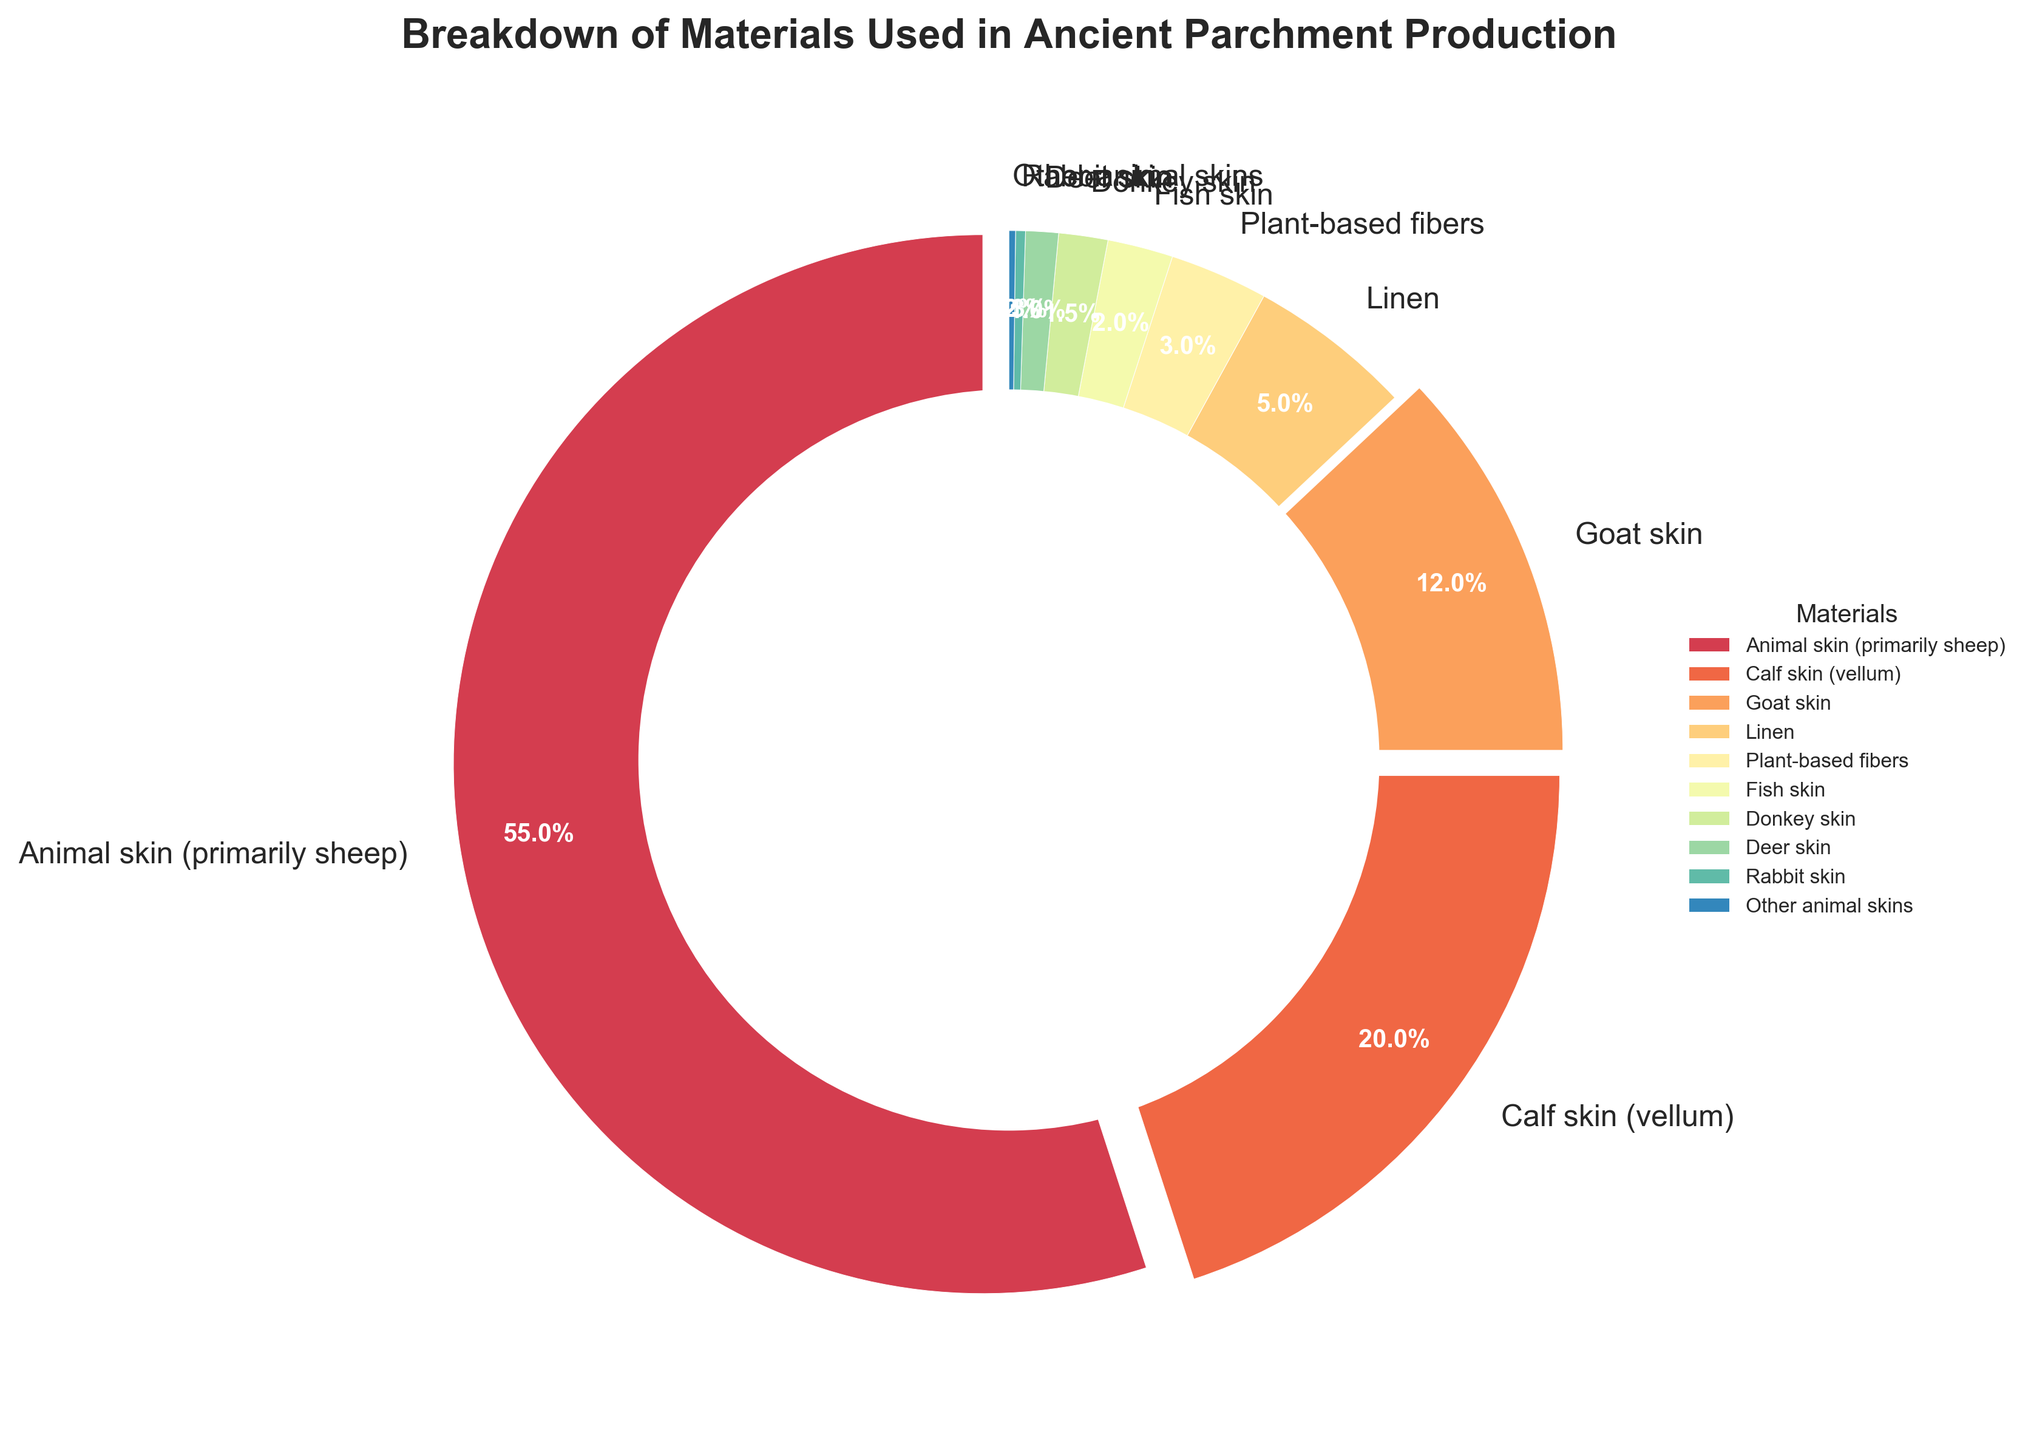What's the largest material used in ancient parchment production by percentage? From the figure, identify the material with the highest percentage. The material segment with the largest slice represents the highest percentage, which is 'Animal skin (primarily sheep)'
Answer: Animal skin (primarily sheep) What is the difference in percentage between animal skin (primarily sheep) and calf skin (vellum)? From the pie chart, find the percentages of both 'Animal skin (primarily sheep)' and 'Calf skin (vellum)'. The percentage for 'Animal skin (primarily sheep)' is 55% and for 'Calf skin (vellum)' is 20%. Subtract the percentage of 'Calf skin (vellum)' from 'Animal skin (primarily sheep)' to get the difference: 55% - 20% = 35%
Answer: 35% How many materials are used in ancient parchment production at a percentage less than 5%? Count the segments of the pie chart that represent percentages less than 5%. These materials are Linen, Plant-based fibers, Fish skin, Donkey skin, Deer skin, Rabbit skin, and Other animal skins. There are 7 segments
Answer: 7 Which material has the smallest representation in the chart? Identify the smallest slice in the pie chart. The smallest segment represents 'Other animal skins' with a percentage of 0.2%
Answer: Other animal skins By how much is goat skin more used compared to fish skin in percentage? From the pie chart, find the percentages of 'Goat skin' and 'Fish skin'. Goat skin is 12% and fish skin is 2%. Subtract the fish skin percentage from the goat skin percentage: 12% - 2% = 10%
Answer: 10% What is the total percentage of parchment materials that are not derived from animal skins? Sum the percentages of the materials that are not from animal skins: Linen (5%) + Plant-based fibers (3%). The total percentage is 5% + 3% = 8%
Answer: 8% What percentage of parchment material is from animal skins, excluding sheep, calf, and goat skins? Sum the percentages of parchment materials excluding sheep, calf, and goat skins. These materials are Fish skin (2%), Donkey skin (1.5%), Deer skin (1%), Rabbit skin (0.3%), and Other animal skins (0.2%). Add their percentages: 2% + 1.5% + 1% + 0.3% + 0.2% = 5%
Answer: 5% Which materials have a percentage representation between 1% and 3%? Check the segments of the pie chart that fall within this range. These materials are Fish skin (2%), Donkey skin (1.5%), Deer skin (1%), and exclude any material with percentages outside of this range
Answer: Fish skin, Donkey skin, Deer skin Compared to deer skin, by what factor is the use of calf skin more common? First, find the percentages of both 'Deer skin' and 'Calf skin (vellum)' from the pie chart. Deer skin is 1% and calf skin is 20%. Divide the percentage of calf skin by that of deer skin: 20 / 1 = 20
Answer: 20 What is the combined percentage of the two least used materials in ancient parchment production? Identify the two materials with the smallest percentages from the pie chart. They are 'Other animal skins' (0.2%) and 'Rabbit skin' (0.3%). Sum their percentages: 0.2% + 0.3% = 0.5%
Answer: 0.5% 